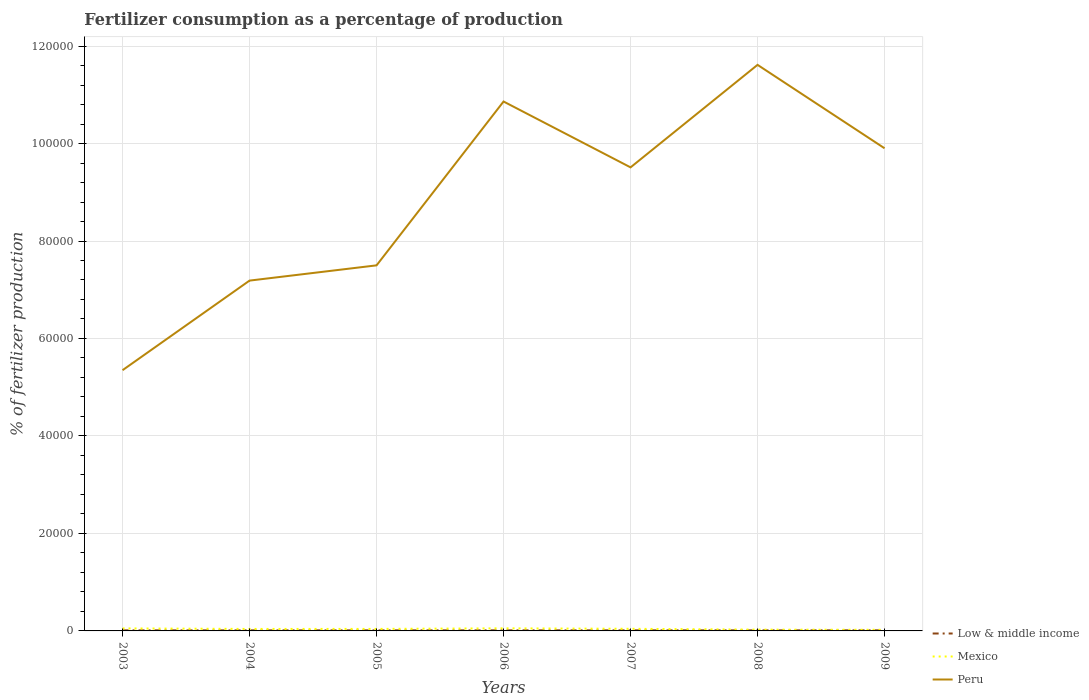Does the line corresponding to Peru intersect with the line corresponding to Mexico?
Offer a very short reply. No. Across all years, what is the maximum percentage of fertilizers consumed in Peru?
Keep it short and to the point. 5.35e+04. In which year was the percentage of fertilizers consumed in Peru maximum?
Make the answer very short. 2003. What is the total percentage of fertilizers consumed in Peru in the graph?
Provide a short and direct response. 1.71e+04. What is the difference between the highest and the second highest percentage of fertilizers consumed in Mexico?
Provide a short and direct response. 294.83. Is the percentage of fertilizers consumed in Low & middle income strictly greater than the percentage of fertilizers consumed in Peru over the years?
Give a very brief answer. Yes. How many lines are there?
Offer a very short reply. 3. How many years are there in the graph?
Offer a terse response. 7. Are the values on the major ticks of Y-axis written in scientific E-notation?
Offer a very short reply. No. What is the title of the graph?
Offer a very short reply. Fertilizer consumption as a percentage of production. What is the label or title of the X-axis?
Provide a short and direct response. Years. What is the label or title of the Y-axis?
Keep it short and to the point. % of fertilizer production. What is the % of fertilizer production in Low & middle income in 2003?
Your answer should be very brief. 119.36. What is the % of fertilizer production of Mexico in 2003?
Your answer should be compact. 514.81. What is the % of fertilizer production of Peru in 2003?
Your answer should be very brief. 5.35e+04. What is the % of fertilizer production in Low & middle income in 2004?
Your response must be concise. 119.38. What is the % of fertilizer production in Mexico in 2004?
Offer a very short reply. 405.44. What is the % of fertilizer production in Peru in 2004?
Keep it short and to the point. 7.19e+04. What is the % of fertilizer production of Low & middle income in 2005?
Keep it short and to the point. 119.15. What is the % of fertilizer production of Mexico in 2005?
Provide a succinct answer. 411.97. What is the % of fertilizer production in Peru in 2005?
Your answer should be very brief. 7.50e+04. What is the % of fertilizer production in Low & middle income in 2006?
Ensure brevity in your answer.  122.79. What is the % of fertilizer production in Mexico in 2006?
Ensure brevity in your answer.  529.39. What is the % of fertilizer production in Peru in 2006?
Offer a very short reply. 1.09e+05. What is the % of fertilizer production of Low & middle income in 2007?
Make the answer very short. 122.79. What is the % of fertilizer production of Mexico in 2007?
Your answer should be very brief. 433.62. What is the % of fertilizer production in Peru in 2007?
Give a very brief answer. 9.51e+04. What is the % of fertilizer production of Low & middle income in 2008?
Ensure brevity in your answer.  119.13. What is the % of fertilizer production of Mexico in 2008?
Your answer should be compact. 266.11. What is the % of fertilizer production of Peru in 2008?
Your response must be concise. 1.16e+05. What is the % of fertilizer production of Low & middle income in 2009?
Ensure brevity in your answer.  121.12. What is the % of fertilizer production of Mexico in 2009?
Keep it short and to the point. 234.56. What is the % of fertilizer production of Peru in 2009?
Ensure brevity in your answer.  9.90e+04. Across all years, what is the maximum % of fertilizer production in Low & middle income?
Keep it short and to the point. 122.79. Across all years, what is the maximum % of fertilizer production in Mexico?
Keep it short and to the point. 529.39. Across all years, what is the maximum % of fertilizer production in Peru?
Your response must be concise. 1.16e+05. Across all years, what is the minimum % of fertilizer production in Low & middle income?
Provide a succinct answer. 119.13. Across all years, what is the minimum % of fertilizer production in Mexico?
Your response must be concise. 234.56. Across all years, what is the minimum % of fertilizer production in Peru?
Provide a succinct answer. 5.35e+04. What is the total % of fertilizer production of Low & middle income in the graph?
Make the answer very short. 843.72. What is the total % of fertilizer production in Mexico in the graph?
Make the answer very short. 2795.89. What is the total % of fertilizer production in Peru in the graph?
Provide a succinct answer. 6.19e+05. What is the difference between the % of fertilizer production in Low & middle income in 2003 and that in 2004?
Your response must be concise. -0.02. What is the difference between the % of fertilizer production in Mexico in 2003 and that in 2004?
Give a very brief answer. 109.37. What is the difference between the % of fertilizer production of Peru in 2003 and that in 2004?
Offer a very short reply. -1.84e+04. What is the difference between the % of fertilizer production in Low & middle income in 2003 and that in 2005?
Your response must be concise. 0.2. What is the difference between the % of fertilizer production in Mexico in 2003 and that in 2005?
Provide a short and direct response. 102.84. What is the difference between the % of fertilizer production of Peru in 2003 and that in 2005?
Give a very brief answer. -2.15e+04. What is the difference between the % of fertilizer production of Low & middle income in 2003 and that in 2006?
Your answer should be very brief. -3.43. What is the difference between the % of fertilizer production in Mexico in 2003 and that in 2006?
Provide a short and direct response. -14.58. What is the difference between the % of fertilizer production of Peru in 2003 and that in 2006?
Your answer should be compact. -5.51e+04. What is the difference between the % of fertilizer production in Low & middle income in 2003 and that in 2007?
Make the answer very short. -3.44. What is the difference between the % of fertilizer production in Mexico in 2003 and that in 2007?
Offer a terse response. 81.18. What is the difference between the % of fertilizer production of Peru in 2003 and that in 2007?
Offer a very short reply. -4.16e+04. What is the difference between the % of fertilizer production of Low & middle income in 2003 and that in 2008?
Provide a short and direct response. 0.22. What is the difference between the % of fertilizer production in Mexico in 2003 and that in 2008?
Offer a very short reply. 248.69. What is the difference between the % of fertilizer production of Peru in 2003 and that in 2008?
Give a very brief answer. -6.26e+04. What is the difference between the % of fertilizer production in Low & middle income in 2003 and that in 2009?
Ensure brevity in your answer.  -1.76. What is the difference between the % of fertilizer production in Mexico in 2003 and that in 2009?
Provide a short and direct response. 280.25. What is the difference between the % of fertilizer production in Peru in 2003 and that in 2009?
Offer a very short reply. -4.55e+04. What is the difference between the % of fertilizer production of Low & middle income in 2004 and that in 2005?
Your answer should be very brief. 0.23. What is the difference between the % of fertilizer production in Mexico in 2004 and that in 2005?
Your response must be concise. -6.53. What is the difference between the % of fertilizer production in Peru in 2004 and that in 2005?
Your response must be concise. -3126.98. What is the difference between the % of fertilizer production in Low & middle income in 2004 and that in 2006?
Keep it short and to the point. -3.41. What is the difference between the % of fertilizer production in Mexico in 2004 and that in 2006?
Provide a short and direct response. -123.95. What is the difference between the % of fertilizer production in Peru in 2004 and that in 2006?
Provide a short and direct response. -3.67e+04. What is the difference between the % of fertilizer production of Low & middle income in 2004 and that in 2007?
Your response must be concise. -3.42. What is the difference between the % of fertilizer production in Mexico in 2004 and that in 2007?
Provide a succinct answer. -28.18. What is the difference between the % of fertilizer production of Peru in 2004 and that in 2007?
Keep it short and to the point. -2.32e+04. What is the difference between the % of fertilizer production of Low & middle income in 2004 and that in 2008?
Offer a terse response. 0.25. What is the difference between the % of fertilizer production of Mexico in 2004 and that in 2008?
Keep it short and to the point. 139.32. What is the difference between the % of fertilizer production of Peru in 2004 and that in 2008?
Ensure brevity in your answer.  -4.43e+04. What is the difference between the % of fertilizer production of Low & middle income in 2004 and that in 2009?
Your response must be concise. -1.74. What is the difference between the % of fertilizer production of Mexico in 2004 and that in 2009?
Keep it short and to the point. 170.88. What is the difference between the % of fertilizer production of Peru in 2004 and that in 2009?
Your answer should be compact. -2.71e+04. What is the difference between the % of fertilizer production in Low & middle income in 2005 and that in 2006?
Your response must be concise. -3.64. What is the difference between the % of fertilizer production in Mexico in 2005 and that in 2006?
Make the answer very short. -117.42. What is the difference between the % of fertilizer production of Peru in 2005 and that in 2006?
Give a very brief answer. -3.36e+04. What is the difference between the % of fertilizer production of Low & middle income in 2005 and that in 2007?
Provide a short and direct response. -3.64. What is the difference between the % of fertilizer production of Mexico in 2005 and that in 2007?
Your answer should be very brief. -21.66. What is the difference between the % of fertilizer production of Peru in 2005 and that in 2007?
Keep it short and to the point. -2.01e+04. What is the difference between the % of fertilizer production in Low & middle income in 2005 and that in 2008?
Provide a succinct answer. 0.02. What is the difference between the % of fertilizer production in Mexico in 2005 and that in 2008?
Offer a very short reply. 145.85. What is the difference between the % of fertilizer production of Peru in 2005 and that in 2008?
Offer a terse response. -4.11e+04. What is the difference between the % of fertilizer production of Low & middle income in 2005 and that in 2009?
Give a very brief answer. -1.97. What is the difference between the % of fertilizer production in Mexico in 2005 and that in 2009?
Offer a very short reply. 177.41. What is the difference between the % of fertilizer production in Peru in 2005 and that in 2009?
Give a very brief answer. -2.40e+04. What is the difference between the % of fertilizer production of Low & middle income in 2006 and that in 2007?
Your answer should be compact. -0.01. What is the difference between the % of fertilizer production of Mexico in 2006 and that in 2007?
Offer a very short reply. 95.76. What is the difference between the % of fertilizer production in Peru in 2006 and that in 2007?
Offer a very short reply. 1.35e+04. What is the difference between the % of fertilizer production in Low & middle income in 2006 and that in 2008?
Offer a very short reply. 3.66. What is the difference between the % of fertilizer production in Mexico in 2006 and that in 2008?
Your answer should be very brief. 263.27. What is the difference between the % of fertilizer production of Peru in 2006 and that in 2008?
Provide a succinct answer. -7523.35. What is the difference between the % of fertilizer production of Low & middle income in 2006 and that in 2009?
Offer a terse response. 1.67. What is the difference between the % of fertilizer production in Mexico in 2006 and that in 2009?
Provide a short and direct response. 294.83. What is the difference between the % of fertilizer production in Peru in 2006 and that in 2009?
Make the answer very short. 9592.44. What is the difference between the % of fertilizer production of Low & middle income in 2007 and that in 2008?
Make the answer very short. 3.66. What is the difference between the % of fertilizer production in Mexico in 2007 and that in 2008?
Provide a succinct answer. 167.51. What is the difference between the % of fertilizer production in Peru in 2007 and that in 2008?
Your answer should be very brief. -2.10e+04. What is the difference between the % of fertilizer production in Low & middle income in 2007 and that in 2009?
Offer a terse response. 1.67. What is the difference between the % of fertilizer production in Mexico in 2007 and that in 2009?
Keep it short and to the point. 199.06. What is the difference between the % of fertilizer production of Peru in 2007 and that in 2009?
Your answer should be compact. -3917.9. What is the difference between the % of fertilizer production of Low & middle income in 2008 and that in 2009?
Your answer should be very brief. -1.99. What is the difference between the % of fertilizer production in Mexico in 2008 and that in 2009?
Your answer should be compact. 31.56. What is the difference between the % of fertilizer production of Peru in 2008 and that in 2009?
Give a very brief answer. 1.71e+04. What is the difference between the % of fertilizer production of Low & middle income in 2003 and the % of fertilizer production of Mexico in 2004?
Provide a succinct answer. -286.08. What is the difference between the % of fertilizer production in Low & middle income in 2003 and the % of fertilizer production in Peru in 2004?
Your answer should be compact. -7.18e+04. What is the difference between the % of fertilizer production in Mexico in 2003 and the % of fertilizer production in Peru in 2004?
Provide a succinct answer. -7.14e+04. What is the difference between the % of fertilizer production of Low & middle income in 2003 and the % of fertilizer production of Mexico in 2005?
Provide a succinct answer. -292.61. What is the difference between the % of fertilizer production in Low & middle income in 2003 and the % of fertilizer production in Peru in 2005?
Your answer should be very brief. -7.49e+04. What is the difference between the % of fertilizer production of Mexico in 2003 and the % of fertilizer production of Peru in 2005?
Give a very brief answer. -7.45e+04. What is the difference between the % of fertilizer production in Low & middle income in 2003 and the % of fertilizer production in Mexico in 2006?
Provide a short and direct response. -410.03. What is the difference between the % of fertilizer production in Low & middle income in 2003 and the % of fertilizer production in Peru in 2006?
Provide a succinct answer. -1.08e+05. What is the difference between the % of fertilizer production of Mexico in 2003 and the % of fertilizer production of Peru in 2006?
Offer a very short reply. -1.08e+05. What is the difference between the % of fertilizer production in Low & middle income in 2003 and the % of fertilizer production in Mexico in 2007?
Make the answer very short. -314.26. What is the difference between the % of fertilizer production in Low & middle income in 2003 and the % of fertilizer production in Peru in 2007?
Offer a very short reply. -9.50e+04. What is the difference between the % of fertilizer production in Mexico in 2003 and the % of fertilizer production in Peru in 2007?
Make the answer very short. -9.46e+04. What is the difference between the % of fertilizer production of Low & middle income in 2003 and the % of fertilizer production of Mexico in 2008?
Make the answer very short. -146.76. What is the difference between the % of fertilizer production in Low & middle income in 2003 and the % of fertilizer production in Peru in 2008?
Make the answer very short. -1.16e+05. What is the difference between the % of fertilizer production in Mexico in 2003 and the % of fertilizer production in Peru in 2008?
Provide a succinct answer. -1.16e+05. What is the difference between the % of fertilizer production of Low & middle income in 2003 and the % of fertilizer production of Mexico in 2009?
Offer a very short reply. -115.2. What is the difference between the % of fertilizer production in Low & middle income in 2003 and the % of fertilizer production in Peru in 2009?
Your response must be concise. -9.89e+04. What is the difference between the % of fertilizer production of Mexico in 2003 and the % of fertilizer production of Peru in 2009?
Offer a terse response. -9.85e+04. What is the difference between the % of fertilizer production in Low & middle income in 2004 and the % of fertilizer production in Mexico in 2005?
Provide a succinct answer. -292.59. What is the difference between the % of fertilizer production of Low & middle income in 2004 and the % of fertilizer production of Peru in 2005?
Your response must be concise. -7.49e+04. What is the difference between the % of fertilizer production of Mexico in 2004 and the % of fertilizer production of Peru in 2005?
Give a very brief answer. -7.46e+04. What is the difference between the % of fertilizer production in Low & middle income in 2004 and the % of fertilizer production in Mexico in 2006?
Provide a succinct answer. -410.01. What is the difference between the % of fertilizer production in Low & middle income in 2004 and the % of fertilizer production in Peru in 2006?
Your response must be concise. -1.08e+05. What is the difference between the % of fertilizer production in Mexico in 2004 and the % of fertilizer production in Peru in 2006?
Give a very brief answer. -1.08e+05. What is the difference between the % of fertilizer production in Low & middle income in 2004 and the % of fertilizer production in Mexico in 2007?
Your answer should be compact. -314.24. What is the difference between the % of fertilizer production in Low & middle income in 2004 and the % of fertilizer production in Peru in 2007?
Your answer should be very brief. -9.50e+04. What is the difference between the % of fertilizer production in Mexico in 2004 and the % of fertilizer production in Peru in 2007?
Keep it short and to the point. -9.47e+04. What is the difference between the % of fertilizer production of Low & middle income in 2004 and the % of fertilizer production of Mexico in 2008?
Your response must be concise. -146.74. What is the difference between the % of fertilizer production in Low & middle income in 2004 and the % of fertilizer production in Peru in 2008?
Your response must be concise. -1.16e+05. What is the difference between the % of fertilizer production of Mexico in 2004 and the % of fertilizer production of Peru in 2008?
Offer a very short reply. -1.16e+05. What is the difference between the % of fertilizer production of Low & middle income in 2004 and the % of fertilizer production of Mexico in 2009?
Provide a succinct answer. -115.18. What is the difference between the % of fertilizer production in Low & middle income in 2004 and the % of fertilizer production in Peru in 2009?
Your answer should be very brief. -9.89e+04. What is the difference between the % of fertilizer production of Mexico in 2004 and the % of fertilizer production of Peru in 2009?
Give a very brief answer. -9.86e+04. What is the difference between the % of fertilizer production of Low & middle income in 2005 and the % of fertilizer production of Mexico in 2006?
Offer a terse response. -410.23. What is the difference between the % of fertilizer production in Low & middle income in 2005 and the % of fertilizer production in Peru in 2006?
Your answer should be compact. -1.08e+05. What is the difference between the % of fertilizer production of Mexico in 2005 and the % of fertilizer production of Peru in 2006?
Ensure brevity in your answer.  -1.08e+05. What is the difference between the % of fertilizer production in Low & middle income in 2005 and the % of fertilizer production in Mexico in 2007?
Make the answer very short. -314.47. What is the difference between the % of fertilizer production of Low & middle income in 2005 and the % of fertilizer production of Peru in 2007?
Ensure brevity in your answer.  -9.50e+04. What is the difference between the % of fertilizer production of Mexico in 2005 and the % of fertilizer production of Peru in 2007?
Your response must be concise. -9.47e+04. What is the difference between the % of fertilizer production of Low & middle income in 2005 and the % of fertilizer production of Mexico in 2008?
Your answer should be compact. -146.96. What is the difference between the % of fertilizer production in Low & middle income in 2005 and the % of fertilizer production in Peru in 2008?
Your answer should be very brief. -1.16e+05. What is the difference between the % of fertilizer production of Mexico in 2005 and the % of fertilizer production of Peru in 2008?
Provide a short and direct response. -1.16e+05. What is the difference between the % of fertilizer production in Low & middle income in 2005 and the % of fertilizer production in Mexico in 2009?
Make the answer very short. -115.41. What is the difference between the % of fertilizer production of Low & middle income in 2005 and the % of fertilizer production of Peru in 2009?
Provide a succinct answer. -9.89e+04. What is the difference between the % of fertilizer production in Mexico in 2005 and the % of fertilizer production in Peru in 2009?
Offer a terse response. -9.86e+04. What is the difference between the % of fertilizer production in Low & middle income in 2006 and the % of fertilizer production in Mexico in 2007?
Your answer should be very brief. -310.83. What is the difference between the % of fertilizer production of Low & middle income in 2006 and the % of fertilizer production of Peru in 2007?
Your answer should be compact. -9.50e+04. What is the difference between the % of fertilizer production of Mexico in 2006 and the % of fertilizer production of Peru in 2007?
Provide a short and direct response. -9.46e+04. What is the difference between the % of fertilizer production in Low & middle income in 2006 and the % of fertilizer production in Mexico in 2008?
Provide a short and direct response. -143.33. What is the difference between the % of fertilizer production in Low & middle income in 2006 and the % of fertilizer production in Peru in 2008?
Your response must be concise. -1.16e+05. What is the difference between the % of fertilizer production of Mexico in 2006 and the % of fertilizer production of Peru in 2008?
Give a very brief answer. -1.16e+05. What is the difference between the % of fertilizer production in Low & middle income in 2006 and the % of fertilizer production in Mexico in 2009?
Provide a short and direct response. -111.77. What is the difference between the % of fertilizer production in Low & middle income in 2006 and the % of fertilizer production in Peru in 2009?
Make the answer very short. -9.89e+04. What is the difference between the % of fertilizer production in Mexico in 2006 and the % of fertilizer production in Peru in 2009?
Offer a terse response. -9.85e+04. What is the difference between the % of fertilizer production of Low & middle income in 2007 and the % of fertilizer production of Mexico in 2008?
Your response must be concise. -143.32. What is the difference between the % of fertilizer production of Low & middle income in 2007 and the % of fertilizer production of Peru in 2008?
Keep it short and to the point. -1.16e+05. What is the difference between the % of fertilizer production in Mexico in 2007 and the % of fertilizer production in Peru in 2008?
Provide a succinct answer. -1.16e+05. What is the difference between the % of fertilizer production of Low & middle income in 2007 and the % of fertilizer production of Mexico in 2009?
Offer a very short reply. -111.76. What is the difference between the % of fertilizer production of Low & middle income in 2007 and the % of fertilizer production of Peru in 2009?
Offer a very short reply. -9.89e+04. What is the difference between the % of fertilizer production of Mexico in 2007 and the % of fertilizer production of Peru in 2009?
Ensure brevity in your answer.  -9.86e+04. What is the difference between the % of fertilizer production in Low & middle income in 2008 and the % of fertilizer production in Mexico in 2009?
Your response must be concise. -115.43. What is the difference between the % of fertilizer production in Low & middle income in 2008 and the % of fertilizer production in Peru in 2009?
Give a very brief answer. -9.89e+04. What is the difference between the % of fertilizer production in Mexico in 2008 and the % of fertilizer production in Peru in 2009?
Your response must be concise. -9.88e+04. What is the average % of fertilizer production in Low & middle income per year?
Provide a succinct answer. 120.53. What is the average % of fertilizer production in Mexico per year?
Provide a succinct answer. 399.41. What is the average % of fertilizer production of Peru per year?
Your answer should be compact. 8.85e+04. In the year 2003, what is the difference between the % of fertilizer production of Low & middle income and % of fertilizer production of Mexico?
Your answer should be compact. -395.45. In the year 2003, what is the difference between the % of fertilizer production of Low & middle income and % of fertilizer production of Peru?
Your answer should be compact. -5.34e+04. In the year 2003, what is the difference between the % of fertilizer production in Mexico and % of fertilizer production in Peru?
Your answer should be compact. -5.30e+04. In the year 2004, what is the difference between the % of fertilizer production in Low & middle income and % of fertilizer production in Mexico?
Offer a very short reply. -286.06. In the year 2004, what is the difference between the % of fertilizer production of Low & middle income and % of fertilizer production of Peru?
Provide a short and direct response. -7.18e+04. In the year 2004, what is the difference between the % of fertilizer production of Mexico and % of fertilizer production of Peru?
Offer a terse response. -7.15e+04. In the year 2005, what is the difference between the % of fertilizer production in Low & middle income and % of fertilizer production in Mexico?
Make the answer very short. -292.81. In the year 2005, what is the difference between the % of fertilizer production of Low & middle income and % of fertilizer production of Peru?
Offer a terse response. -7.49e+04. In the year 2005, what is the difference between the % of fertilizer production in Mexico and % of fertilizer production in Peru?
Give a very brief answer. -7.46e+04. In the year 2006, what is the difference between the % of fertilizer production of Low & middle income and % of fertilizer production of Mexico?
Offer a very short reply. -406.6. In the year 2006, what is the difference between the % of fertilizer production of Low & middle income and % of fertilizer production of Peru?
Offer a terse response. -1.08e+05. In the year 2006, what is the difference between the % of fertilizer production of Mexico and % of fertilizer production of Peru?
Keep it short and to the point. -1.08e+05. In the year 2007, what is the difference between the % of fertilizer production in Low & middle income and % of fertilizer production in Mexico?
Provide a succinct answer. -310.83. In the year 2007, what is the difference between the % of fertilizer production of Low & middle income and % of fertilizer production of Peru?
Ensure brevity in your answer.  -9.50e+04. In the year 2007, what is the difference between the % of fertilizer production in Mexico and % of fertilizer production in Peru?
Give a very brief answer. -9.47e+04. In the year 2008, what is the difference between the % of fertilizer production in Low & middle income and % of fertilizer production in Mexico?
Your response must be concise. -146.98. In the year 2008, what is the difference between the % of fertilizer production in Low & middle income and % of fertilizer production in Peru?
Provide a short and direct response. -1.16e+05. In the year 2008, what is the difference between the % of fertilizer production of Mexico and % of fertilizer production of Peru?
Provide a short and direct response. -1.16e+05. In the year 2009, what is the difference between the % of fertilizer production of Low & middle income and % of fertilizer production of Mexico?
Your response must be concise. -113.44. In the year 2009, what is the difference between the % of fertilizer production of Low & middle income and % of fertilizer production of Peru?
Give a very brief answer. -9.89e+04. In the year 2009, what is the difference between the % of fertilizer production of Mexico and % of fertilizer production of Peru?
Give a very brief answer. -9.88e+04. What is the ratio of the % of fertilizer production in Mexico in 2003 to that in 2004?
Give a very brief answer. 1.27. What is the ratio of the % of fertilizer production of Peru in 2003 to that in 2004?
Keep it short and to the point. 0.74. What is the ratio of the % of fertilizer production in Mexico in 2003 to that in 2005?
Give a very brief answer. 1.25. What is the ratio of the % of fertilizer production of Peru in 2003 to that in 2005?
Your answer should be compact. 0.71. What is the ratio of the % of fertilizer production in Low & middle income in 2003 to that in 2006?
Offer a terse response. 0.97. What is the ratio of the % of fertilizer production of Mexico in 2003 to that in 2006?
Make the answer very short. 0.97. What is the ratio of the % of fertilizer production of Peru in 2003 to that in 2006?
Make the answer very short. 0.49. What is the ratio of the % of fertilizer production of Low & middle income in 2003 to that in 2007?
Your answer should be compact. 0.97. What is the ratio of the % of fertilizer production of Mexico in 2003 to that in 2007?
Ensure brevity in your answer.  1.19. What is the ratio of the % of fertilizer production of Peru in 2003 to that in 2007?
Your answer should be compact. 0.56. What is the ratio of the % of fertilizer production of Low & middle income in 2003 to that in 2008?
Make the answer very short. 1. What is the ratio of the % of fertilizer production of Mexico in 2003 to that in 2008?
Provide a succinct answer. 1.93. What is the ratio of the % of fertilizer production of Peru in 2003 to that in 2008?
Provide a short and direct response. 0.46. What is the ratio of the % of fertilizer production of Low & middle income in 2003 to that in 2009?
Your response must be concise. 0.99. What is the ratio of the % of fertilizer production in Mexico in 2003 to that in 2009?
Give a very brief answer. 2.19. What is the ratio of the % of fertilizer production of Peru in 2003 to that in 2009?
Give a very brief answer. 0.54. What is the ratio of the % of fertilizer production of Low & middle income in 2004 to that in 2005?
Ensure brevity in your answer.  1. What is the ratio of the % of fertilizer production of Mexico in 2004 to that in 2005?
Provide a succinct answer. 0.98. What is the ratio of the % of fertilizer production in Peru in 2004 to that in 2005?
Offer a very short reply. 0.96. What is the ratio of the % of fertilizer production in Low & middle income in 2004 to that in 2006?
Give a very brief answer. 0.97. What is the ratio of the % of fertilizer production of Mexico in 2004 to that in 2006?
Provide a succinct answer. 0.77. What is the ratio of the % of fertilizer production in Peru in 2004 to that in 2006?
Ensure brevity in your answer.  0.66. What is the ratio of the % of fertilizer production in Low & middle income in 2004 to that in 2007?
Your answer should be very brief. 0.97. What is the ratio of the % of fertilizer production in Mexico in 2004 to that in 2007?
Your answer should be very brief. 0.94. What is the ratio of the % of fertilizer production in Peru in 2004 to that in 2007?
Make the answer very short. 0.76. What is the ratio of the % of fertilizer production in Mexico in 2004 to that in 2008?
Give a very brief answer. 1.52. What is the ratio of the % of fertilizer production of Peru in 2004 to that in 2008?
Give a very brief answer. 0.62. What is the ratio of the % of fertilizer production of Low & middle income in 2004 to that in 2009?
Give a very brief answer. 0.99. What is the ratio of the % of fertilizer production of Mexico in 2004 to that in 2009?
Make the answer very short. 1.73. What is the ratio of the % of fertilizer production of Peru in 2004 to that in 2009?
Your answer should be compact. 0.73. What is the ratio of the % of fertilizer production of Low & middle income in 2005 to that in 2006?
Offer a very short reply. 0.97. What is the ratio of the % of fertilizer production of Mexico in 2005 to that in 2006?
Keep it short and to the point. 0.78. What is the ratio of the % of fertilizer production in Peru in 2005 to that in 2006?
Offer a very short reply. 0.69. What is the ratio of the % of fertilizer production of Low & middle income in 2005 to that in 2007?
Ensure brevity in your answer.  0.97. What is the ratio of the % of fertilizer production of Mexico in 2005 to that in 2007?
Your answer should be very brief. 0.95. What is the ratio of the % of fertilizer production in Peru in 2005 to that in 2007?
Ensure brevity in your answer.  0.79. What is the ratio of the % of fertilizer production of Low & middle income in 2005 to that in 2008?
Your response must be concise. 1. What is the ratio of the % of fertilizer production of Mexico in 2005 to that in 2008?
Give a very brief answer. 1.55. What is the ratio of the % of fertilizer production in Peru in 2005 to that in 2008?
Make the answer very short. 0.65. What is the ratio of the % of fertilizer production of Low & middle income in 2005 to that in 2009?
Your response must be concise. 0.98. What is the ratio of the % of fertilizer production in Mexico in 2005 to that in 2009?
Offer a very short reply. 1.76. What is the ratio of the % of fertilizer production in Peru in 2005 to that in 2009?
Offer a very short reply. 0.76. What is the ratio of the % of fertilizer production in Mexico in 2006 to that in 2007?
Your response must be concise. 1.22. What is the ratio of the % of fertilizer production of Peru in 2006 to that in 2007?
Your answer should be compact. 1.14. What is the ratio of the % of fertilizer production in Low & middle income in 2006 to that in 2008?
Keep it short and to the point. 1.03. What is the ratio of the % of fertilizer production in Mexico in 2006 to that in 2008?
Keep it short and to the point. 1.99. What is the ratio of the % of fertilizer production of Peru in 2006 to that in 2008?
Provide a short and direct response. 0.94. What is the ratio of the % of fertilizer production in Low & middle income in 2006 to that in 2009?
Ensure brevity in your answer.  1.01. What is the ratio of the % of fertilizer production in Mexico in 2006 to that in 2009?
Give a very brief answer. 2.26. What is the ratio of the % of fertilizer production of Peru in 2006 to that in 2009?
Your answer should be compact. 1.1. What is the ratio of the % of fertilizer production of Low & middle income in 2007 to that in 2008?
Provide a short and direct response. 1.03. What is the ratio of the % of fertilizer production of Mexico in 2007 to that in 2008?
Give a very brief answer. 1.63. What is the ratio of the % of fertilizer production of Peru in 2007 to that in 2008?
Provide a short and direct response. 0.82. What is the ratio of the % of fertilizer production of Low & middle income in 2007 to that in 2009?
Your answer should be very brief. 1.01. What is the ratio of the % of fertilizer production of Mexico in 2007 to that in 2009?
Your answer should be very brief. 1.85. What is the ratio of the % of fertilizer production of Peru in 2007 to that in 2009?
Provide a short and direct response. 0.96. What is the ratio of the % of fertilizer production of Low & middle income in 2008 to that in 2009?
Your answer should be very brief. 0.98. What is the ratio of the % of fertilizer production of Mexico in 2008 to that in 2009?
Your response must be concise. 1.13. What is the ratio of the % of fertilizer production in Peru in 2008 to that in 2009?
Provide a succinct answer. 1.17. What is the difference between the highest and the second highest % of fertilizer production in Low & middle income?
Keep it short and to the point. 0.01. What is the difference between the highest and the second highest % of fertilizer production in Mexico?
Your answer should be very brief. 14.58. What is the difference between the highest and the second highest % of fertilizer production in Peru?
Provide a succinct answer. 7523.35. What is the difference between the highest and the lowest % of fertilizer production in Low & middle income?
Give a very brief answer. 3.66. What is the difference between the highest and the lowest % of fertilizer production in Mexico?
Your response must be concise. 294.83. What is the difference between the highest and the lowest % of fertilizer production of Peru?
Keep it short and to the point. 6.26e+04. 